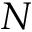Convert formula to latex. <formula><loc_0><loc_0><loc_500><loc_500>N</formula> 